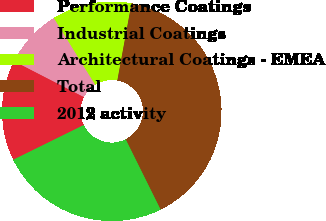<chart> <loc_0><loc_0><loc_500><loc_500><pie_chart><fcel>Performance Coatings<fcel>Industrial Coatings<fcel>Architectural Coatings - EMEA<fcel>Total<fcel>2012 activity<nl><fcel>14.84%<fcel>8.61%<fcel>11.72%<fcel>39.78%<fcel>25.05%<nl></chart> 